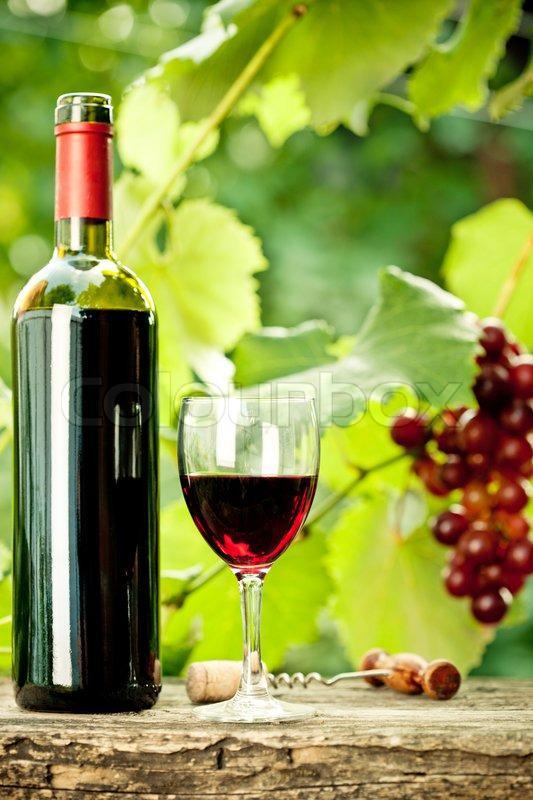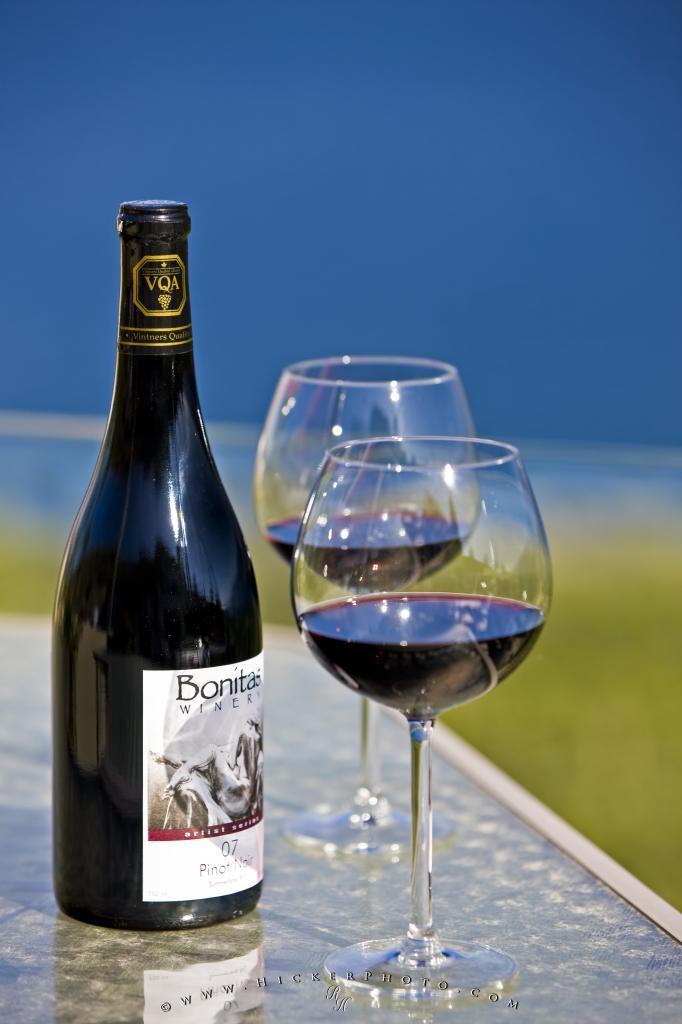The first image is the image on the left, the second image is the image on the right. Assess this claim about the two images: "There is a red bottle of wine with a red top mostly full to the left of a single stemed glass of  red wine filled to the halfway point.". Correct or not? Answer yes or no. Yes. 